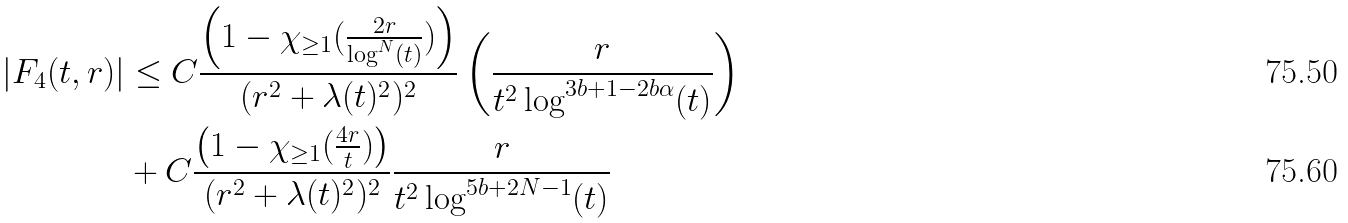Convert formula to latex. <formula><loc_0><loc_0><loc_500><loc_500>| F _ { 4 } ( t , r ) | & \leq C \frac { \left ( 1 - \chi _ { \geq 1 } ( \frac { 2 r } { \log ^ { N } ( t ) } ) \right ) } { ( r ^ { 2 } + \lambda ( t ) ^ { 2 } ) ^ { 2 } } \left ( \frac { r } { t ^ { 2 } \log ^ { 3 b + 1 - 2 b \alpha } ( t ) } \right ) \\ & + C \frac { \left ( 1 - \chi _ { \geq 1 } ( \frac { 4 r } { t } ) \right ) } { ( r ^ { 2 } + \lambda ( t ) ^ { 2 } ) ^ { 2 } } \frac { r } { t ^ { 2 } \log ^ { 5 b + 2 N - 1 } ( t ) }</formula> 